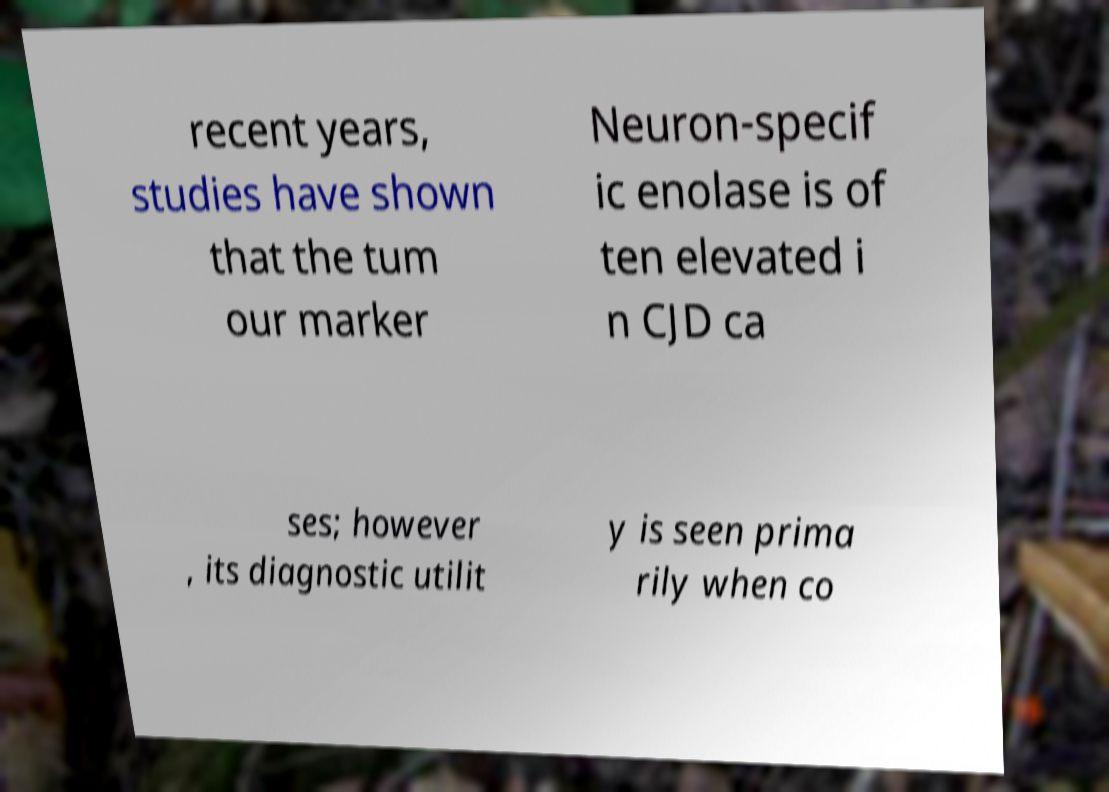Please identify and transcribe the text found in this image. recent years, studies have shown that the tum our marker Neuron-specif ic enolase is of ten elevated i n CJD ca ses; however , its diagnostic utilit y is seen prima rily when co 